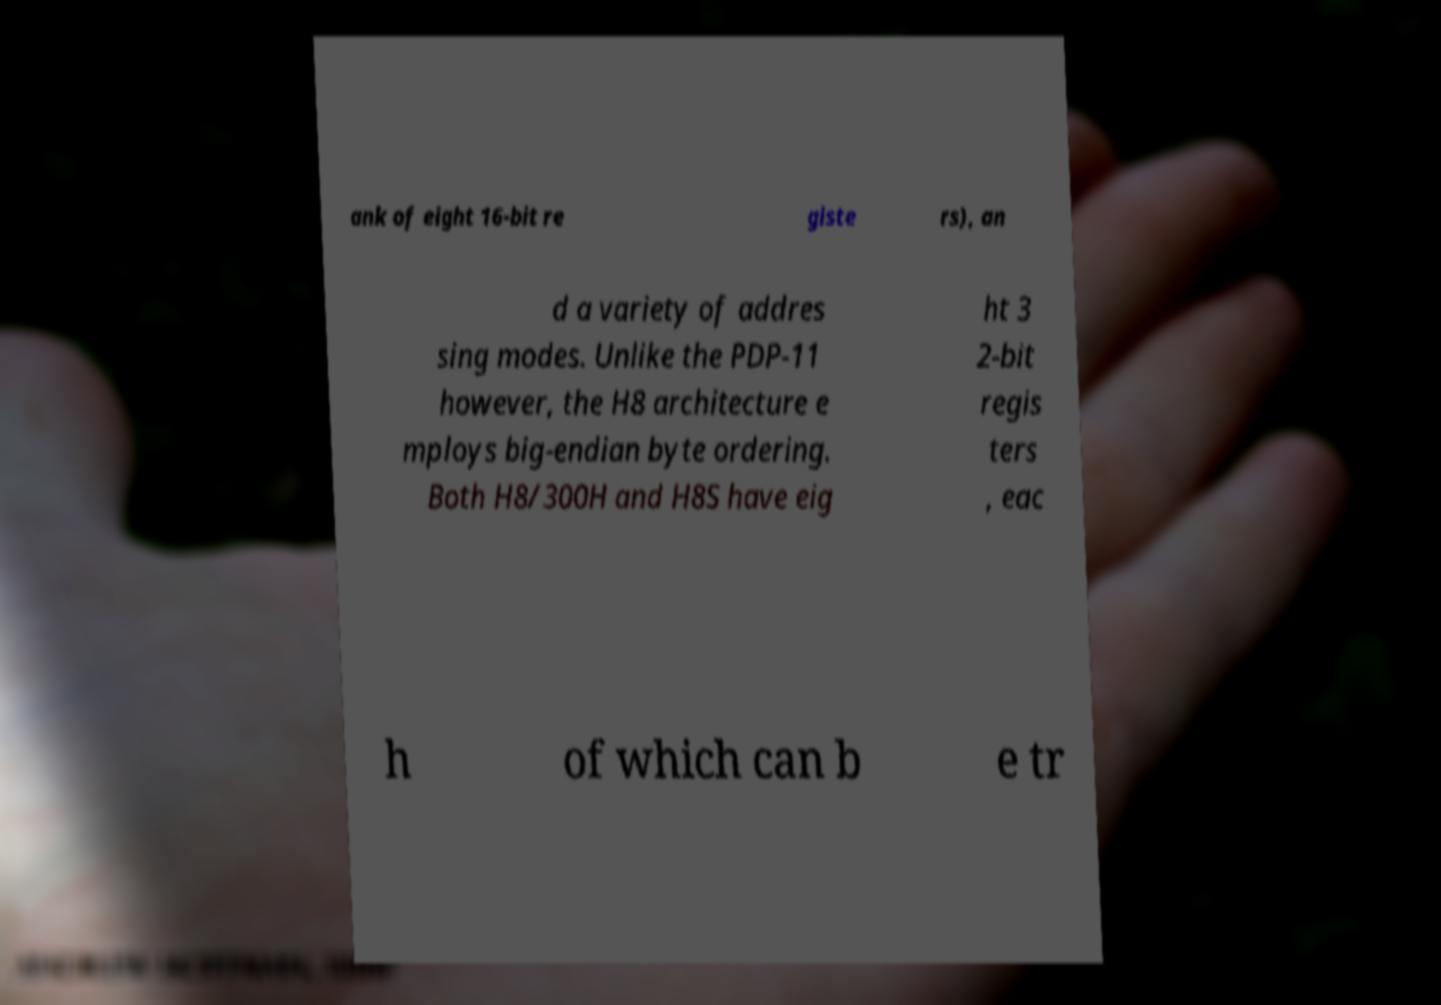There's text embedded in this image that I need extracted. Can you transcribe it verbatim? ank of eight 16-bit re giste rs), an d a variety of addres sing modes. Unlike the PDP-11 however, the H8 architecture e mploys big-endian byte ordering. Both H8/300H and H8S have eig ht 3 2-bit regis ters , eac h of which can b e tr 